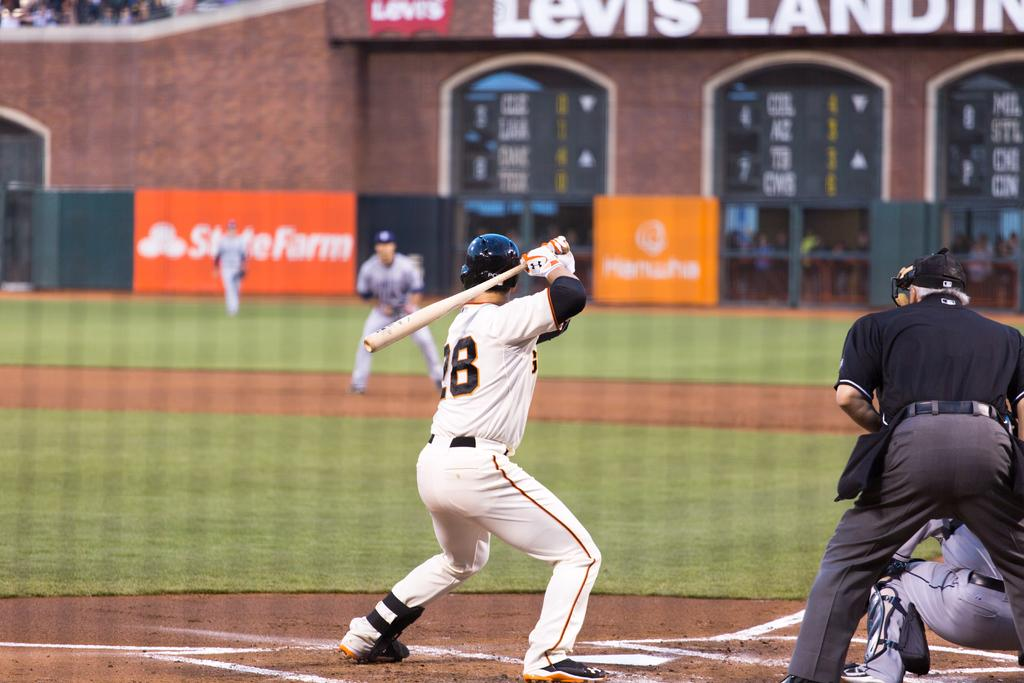<image>
Share a concise interpretation of the image provided. Player number 28 holds up the baseball bat in preparation for a hit. 